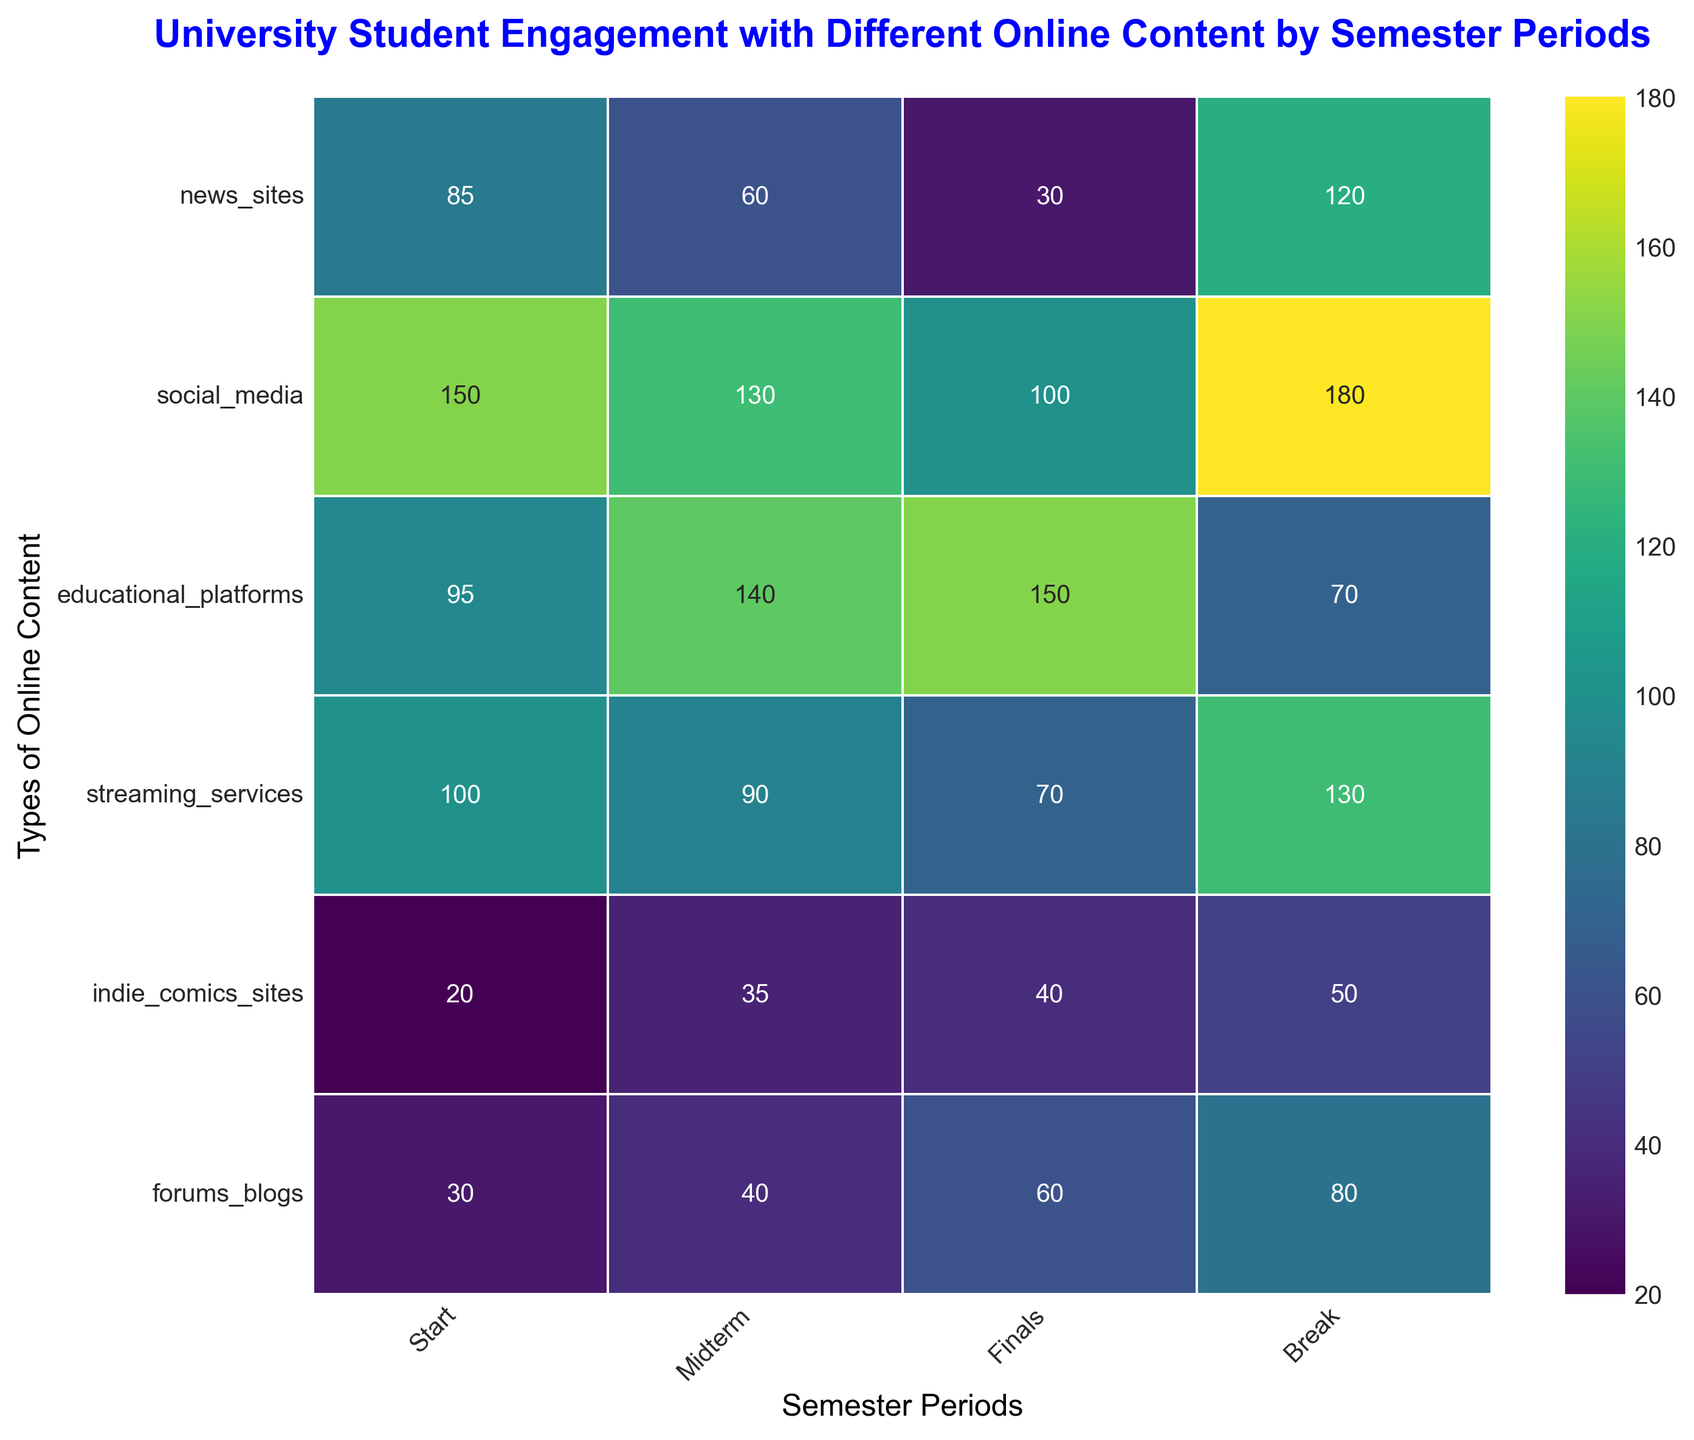Which semester period has the highest engagement with streaming services? Look at the column for streaming services and identify the highest value. The highest value is 130 during the Break period.
Answer: Break Which type of online content has the lowest engagement during the Midterm period? Look at the Midterm column and identify the lowest value among all types. The lowest value is 35 for indie comics sites.
Answer: Indie comics sites What is the sum of student engagement with social media and forums/blogs during the Finals period? Look at the columns for social media and forums/blogs during the Finals period and add their values. 100 (social media) + 60 (forums/blogs) = 160.
Answer: 160 What is the average student engagement with educational platforms across all semester periods? Find the values for educational platforms across all periods (95, 140, 150, 70), sum them up and divide by 4. (95 + 140 + 150 + 70) / 4 = 112.5
Answer: 112.5 Is student engagement with news sites higher during the Break period or the Start period? Compare the values of news sites during the Break (120) and Start (85) periods to see which is higher. 120 (Break) is higher than 85 (Start).
Answer: Break What is the difference in student engagement with social media between the Start and Finals periods? Subtract the value for social media during the Finals period from the value during the Start period. 150 (Start) - 100 (Finals) = 50.
Answer: 50 During which period do students engage with indie comics sites the most? Look at the column for indie comics sites and find the highest value. The highest value is 50 during the Break period.
Answer: Break What is the color gradient in the heatmap representing the highest engagement levels? Notice the color assigned to the highest numbers in the figure. The highest values (such as 180 for social media during the Break period) are represented in a dark hue.
Answer: Dark How does student engagement with forums/blogs during the Break period compare to the Start period? Compare the values for forums/blogs during the Start (30) and Break (80) periods. 80 (Break) > 30 (Start).
Answer: Higher Which type of online content has a consistent increase in engagement from Start to Finals? Look at each type of content from Start to Finals and check for consistent increases. Educational platforms show a consistent increase: 95 (Start) < 140 (Midterm) < 150 (Finals).
Answer: Educational platforms 